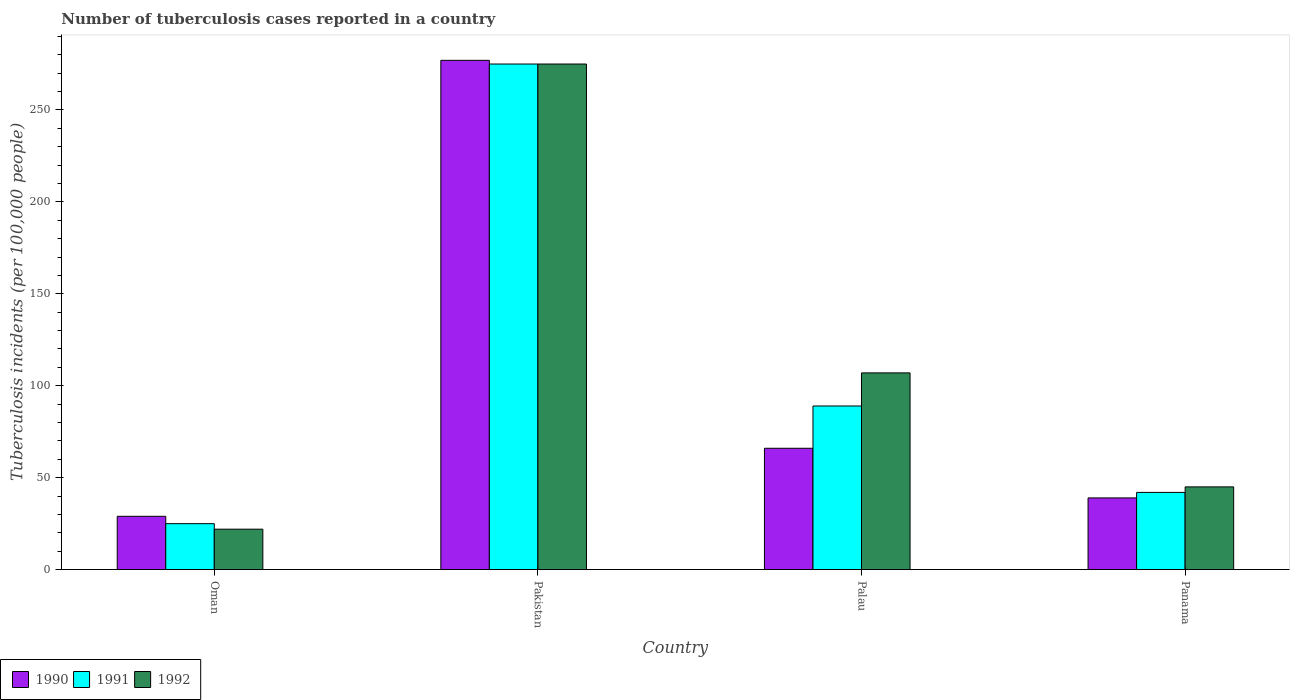How many different coloured bars are there?
Offer a terse response. 3. What is the label of the 3rd group of bars from the left?
Offer a terse response. Palau. In how many cases, is the number of bars for a given country not equal to the number of legend labels?
Ensure brevity in your answer.  0. What is the number of tuberculosis cases reported in in 1992 in Pakistan?
Your answer should be very brief. 275. Across all countries, what is the maximum number of tuberculosis cases reported in in 1992?
Provide a short and direct response. 275. In which country was the number of tuberculosis cases reported in in 1991 maximum?
Offer a terse response. Pakistan. In which country was the number of tuberculosis cases reported in in 1992 minimum?
Your answer should be compact. Oman. What is the total number of tuberculosis cases reported in in 1991 in the graph?
Give a very brief answer. 431. What is the average number of tuberculosis cases reported in in 1992 per country?
Your answer should be compact. 112.25. What is the ratio of the number of tuberculosis cases reported in in 1992 in Palau to that in Panama?
Provide a succinct answer. 2.38. Is the number of tuberculosis cases reported in in 1992 in Palau less than that in Panama?
Provide a succinct answer. No. Is the difference between the number of tuberculosis cases reported in in 1990 in Palau and Panama greater than the difference between the number of tuberculosis cases reported in in 1991 in Palau and Panama?
Offer a terse response. No. What is the difference between the highest and the second highest number of tuberculosis cases reported in in 1992?
Keep it short and to the point. -168. What is the difference between the highest and the lowest number of tuberculosis cases reported in in 1990?
Your answer should be compact. 248. Is the sum of the number of tuberculosis cases reported in in 1991 in Oman and Panama greater than the maximum number of tuberculosis cases reported in in 1990 across all countries?
Provide a short and direct response. No. What does the 1st bar from the left in Palau represents?
Provide a short and direct response. 1990. Is it the case that in every country, the sum of the number of tuberculosis cases reported in in 1992 and number of tuberculosis cases reported in in 1990 is greater than the number of tuberculosis cases reported in in 1991?
Offer a terse response. Yes. How many countries are there in the graph?
Your answer should be very brief. 4. Are the values on the major ticks of Y-axis written in scientific E-notation?
Provide a succinct answer. No. Does the graph contain any zero values?
Provide a succinct answer. No. Where does the legend appear in the graph?
Your answer should be very brief. Bottom left. How are the legend labels stacked?
Provide a succinct answer. Horizontal. What is the title of the graph?
Your answer should be very brief. Number of tuberculosis cases reported in a country. Does "1999" appear as one of the legend labels in the graph?
Give a very brief answer. No. What is the label or title of the X-axis?
Your response must be concise. Country. What is the label or title of the Y-axis?
Offer a very short reply. Tuberculosis incidents (per 100,0 people). What is the Tuberculosis incidents (per 100,000 people) of 1990 in Oman?
Keep it short and to the point. 29. What is the Tuberculosis incidents (per 100,000 people) of 1990 in Pakistan?
Ensure brevity in your answer.  277. What is the Tuberculosis incidents (per 100,000 people) of 1991 in Pakistan?
Offer a very short reply. 275. What is the Tuberculosis incidents (per 100,000 people) of 1992 in Pakistan?
Provide a short and direct response. 275. What is the Tuberculosis incidents (per 100,000 people) of 1990 in Palau?
Your answer should be very brief. 66. What is the Tuberculosis incidents (per 100,000 people) in 1991 in Palau?
Your answer should be very brief. 89. What is the Tuberculosis incidents (per 100,000 people) of 1992 in Palau?
Your answer should be very brief. 107. What is the Tuberculosis incidents (per 100,000 people) in 1992 in Panama?
Provide a succinct answer. 45. Across all countries, what is the maximum Tuberculosis incidents (per 100,000 people) of 1990?
Provide a short and direct response. 277. Across all countries, what is the maximum Tuberculosis incidents (per 100,000 people) in 1991?
Keep it short and to the point. 275. Across all countries, what is the maximum Tuberculosis incidents (per 100,000 people) of 1992?
Keep it short and to the point. 275. Across all countries, what is the minimum Tuberculosis incidents (per 100,000 people) in 1990?
Offer a very short reply. 29. What is the total Tuberculosis incidents (per 100,000 people) in 1990 in the graph?
Provide a succinct answer. 411. What is the total Tuberculosis incidents (per 100,000 people) of 1991 in the graph?
Give a very brief answer. 431. What is the total Tuberculosis incidents (per 100,000 people) in 1992 in the graph?
Provide a succinct answer. 449. What is the difference between the Tuberculosis incidents (per 100,000 people) of 1990 in Oman and that in Pakistan?
Give a very brief answer. -248. What is the difference between the Tuberculosis incidents (per 100,000 people) in 1991 in Oman and that in Pakistan?
Offer a very short reply. -250. What is the difference between the Tuberculosis incidents (per 100,000 people) of 1992 in Oman and that in Pakistan?
Offer a terse response. -253. What is the difference between the Tuberculosis incidents (per 100,000 people) of 1990 in Oman and that in Palau?
Ensure brevity in your answer.  -37. What is the difference between the Tuberculosis incidents (per 100,000 people) in 1991 in Oman and that in Palau?
Provide a short and direct response. -64. What is the difference between the Tuberculosis incidents (per 100,000 people) of 1992 in Oman and that in Palau?
Ensure brevity in your answer.  -85. What is the difference between the Tuberculosis incidents (per 100,000 people) of 1990 in Pakistan and that in Palau?
Provide a succinct answer. 211. What is the difference between the Tuberculosis incidents (per 100,000 people) in 1991 in Pakistan and that in Palau?
Make the answer very short. 186. What is the difference between the Tuberculosis incidents (per 100,000 people) in 1992 in Pakistan and that in Palau?
Keep it short and to the point. 168. What is the difference between the Tuberculosis incidents (per 100,000 people) of 1990 in Pakistan and that in Panama?
Your answer should be compact. 238. What is the difference between the Tuberculosis incidents (per 100,000 people) in 1991 in Pakistan and that in Panama?
Provide a succinct answer. 233. What is the difference between the Tuberculosis incidents (per 100,000 people) of 1992 in Pakistan and that in Panama?
Keep it short and to the point. 230. What is the difference between the Tuberculosis incidents (per 100,000 people) in 1990 in Palau and that in Panama?
Keep it short and to the point. 27. What is the difference between the Tuberculosis incidents (per 100,000 people) in 1990 in Oman and the Tuberculosis incidents (per 100,000 people) in 1991 in Pakistan?
Your answer should be very brief. -246. What is the difference between the Tuberculosis incidents (per 100,000 people) in 1990 in Oman and the Tuberculosis incidents (per 100,000 people) in 1992 in Pakistan?
Keep it short and to the point. -246. What is the difference between the Tuberculosis incidents (per 100,000 people) in 1991 in Oman and the Tuberculosis incidents (per 100,000 people) in 1992 in Pakistan?
Your response must be concise. -250. What is the difference between the Tuberculosis incidents (per 100,000 people) in 1990 in Oman and the Tuberculosis incidents (per 100,000 people) in 1991 in Palau?
Provide a succinct answer. -60. What is the difference between the Tuberculosis incidents (per 100,000 people) in 1990 in Oman and the Tuberculosis incidents (per 100,000 people) in 1992 in Palau?
Your answer should be very brief. -78. What is the difference between the Tuberculosis incidents (per 100,000 people) of 1991 in Oman and the Tuberculosis incidents (per 100,000 people) of 1992 in Palau?
Your answer should be compact. -82. What is the difference between the Tuberculosis incidents (per 100,000 people) of 1990 in Oman and the Tuberculosis incidents (per 100,000 people) of 1991 in Panama?
Make the answer very short. -13. What is the difference between the Tuberculosis incidents (per 100,000 people) in 1990 in Oman and the Tuberculosis incidents (per 100,000 people) in 1992 in Panama?
Your response must be concise. -16. What is the difference between the Tuberculosis incidents (per 100,000 people) of 1990 in Pakistan and the Tuberculosis incidents (per 100,000 people) of 1991 in Palau?
Ensure brevity in your answer.  188. What is the difference between the Tuberculosis incidents (per 100,000 people) of 1990 in Pakistan and the Tuberculosis incidents (per 100,000 people) of 1992 in Palau?
Provide a short and direct response. 170. What is the difference between the Tuberculosis incidents (per 100,000 people) of 1991 in Pakistan and the Tuberculosis incidents (per 100,000 people) of 1992 in Palau?
Your response must be concise. 168. What is the difference between the Tuberculosis incidents (per 100,000 people) in 1990 in Pakistan and the Tuberculosis incidents (per 100,000 people) in 1991 in Panama?
Ensure brevity in your answer.  235. What is the difference between the Tuberculosis incidents (per 100,000 people) of 1990 in Pakistan and the Tuberculosis incidents (per 100,000 people) of 1992 in Panama?
Your response must be concise. 232. What is the difference between the Tuberculosis incidents (per 100,000 people) of 1991 in Pakistan and the Tuberculosis incidents (per 100,000 people) of 1992 in Panama?
Provide a succinct answer. 230. What is the difference between the Tuberculosis incidents (per 100,000 people) in 1990 in Palau and the Tuberculosis incidents (per 100,000 people) in 1991 in Panama?
Your response must be concise. 24. What is the difference between the Tuberculosis incidents (per 100,000 people) in 1990 in Palau and the Tuberculosis incidents (per 100,000 people) in 1992 in Panama?
Provide a short and direct response. 21. What is the average Tuberculosis incidents (per 100,000 people) of 1990 per country?
Provide a succinct answer. 102.75. What is the average Tuberculosis incidents (per 100,000 people) of 1991 per country?
Offer a very short reply. 107.75. What is the average Tuberculosis incidents (per 100,000 people) of 1992 per country?
Your response must be concise. 112.25. What is the difference between the Tuberculosis incidents (per 100,000 people) in 1990 and Tuberculosis incidents (per 100,000 people) in 1992 in Oman?
Your answer should be very brief. 7. What is the difference between the Tuberculosis incidents (per 100,000 people) in 1991 and Tuberculosis incidents (per 100,000 people) in 1992 in Pakistan?
Keep it short and to the point. 0. What is the difference between the Tuberculosis incidents (per 100,000 people) of 1990 and Tuberculosis incidents (per 100,000 people) of 1992 in Palau?
Give a very brief answer. -41. What is the difference between the Tuberculosis incidents (per 100,000 people) of 1990 and Tuberculosis incidents (per 100,000 people) of 1991 in Panama?
Your response must be concise. -3. What is the ratio of the Tuberculosis incidents (per 100,000 people) in 1990 in Oman to that in Pakistan?
Ensure brevity in your answer.  0.1. What is the ratio of the Tuberculosis incidents (per 100,000 people) of 1991 in Oman to that in Pakistan?
Offer a terse response. 0.09. What is the ratio of the Tuberculosis incidents (per 100,000 people) in 1990 in Oman to that in Palau?
Provide a short and direct response. 0.44. What is the ratio of the Tuberculosis incidents (per 100,000 people) of 1991 in Oman to that in Palau?
Make the answer very short. 0.28. What is the ratio of the Tuberculosis incidents (per 100,000 people) of 1992 in Oman to that in Palau?
Your answer should be very brief. 0.21. What is the ratio of the Tuberculosis incidents (per 100,000 people) of 1990 in Oman to that in Panama?
Your answer should be compact. 0.74. What is the ratio of the Tuberculosis incidents (per 100,000 people) of 1991 in Oman to that in Panama?
Ensure brevity in your answer.  0.6. What is the ratio of the Tuberculosis incidents (per 100,000 people) in 1992 in Oman to that in Panama?
Make the answer very short. 0.49. What is the ratio of the Tuberculosis incidents (per 100,000 people) of 1990 in Pakistan to that in Palau?
Ensure brevity in your answer.  4.2. What is the ratio of the Tuberculosis incidents (per 100,000 people) in 1991 in Pakistan to that in Palau?
Your response must be concise. 3.09. What is the ratio of the Tuberculosis incidents (per 100,000 people) in 1992 in Pakistan to that in Palau?
Give a very brief answer. 2.57. What is the ratio of the Tuberculosis incidents (per 100,000 people) in 1990 in Pakistan to that in Panama?
Offer a very short reply. 7.1. What is the ratio of the Tuberculosis incidents (per 100,000 people) of 1991 in Pakistan to that in Panama?
Offer a very short reply. 6.55. What is the ratio of the Tuberculosis incidents (per 100,000 people) in 1992 in Pakistan to that in Panama?
Provide a succinct answer. 6.11. What is the ratio of the Tuberculosis incidents (per 100,000 people) in 1990 in Palau to that in Panama?
Provide a succinct answer. 1.69. What is the ratio of the Tuberculosis incidents (per 100,000 people) in 1991 in Palau to that in Panama?
Ensure brevity in your answer.  2.12. What is the ratio of the Tuberculosis incidents (per 100,000 people) of 1992 in Palau to that in Panama?
Provide a succinct answer. 2.38. What is the difference between the highest and the second highest Tuberculosis incidents (per 100,000 people) in 1990?
Your response must be concise. 211. What is the difference between the highest and the second highest Tuberculosis incidents (per 100,000 people) in 1991?
Offer a terse response. 186. What is the difference between the highest and the second highest Tuberculosis incidents (per 100,000 people) in 1992?
Keep it short and to the point. 168. What is the difference between the highest and the lowest Tuberculosis incidents (per 100,000 people) in 1990?
Offer a very short reply. 248. What is the difference between the highest and the lowest Tuberculosis incidents (per 100,000 people) in 1991?
Offer a terse response. 250. What is the difference between the highest and the lowest Tuberculosis incidents (per 100,000 people) in 1992?
Provide a short and direct response. 253. 